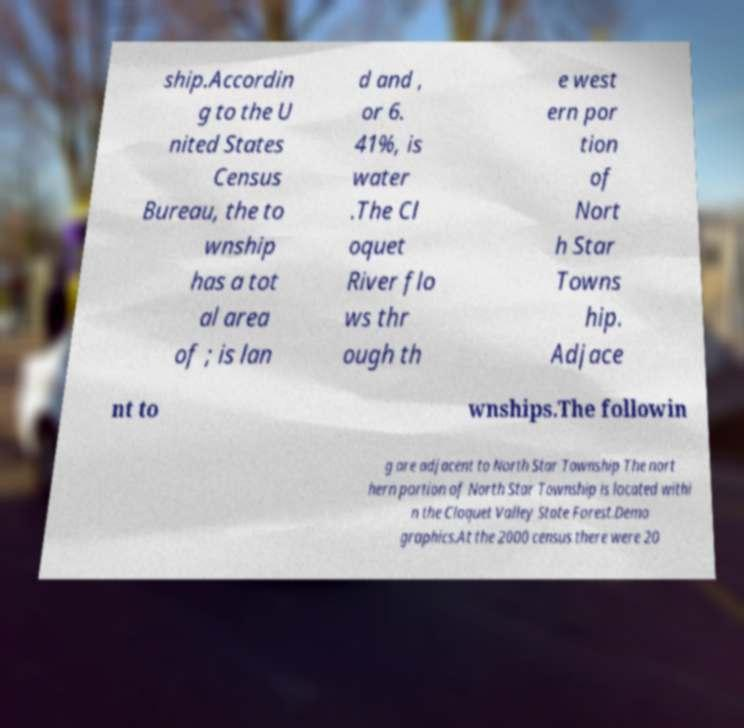Please read and relay the text visible in this image. What does it say? ship.Accordin g to the U nited States Census Bureau, the to wnship has a tot al area of ; is lan d and , or 6. 41%, is water .The Cl oquet River flo ws thr ough th e west ern por tion of Nort h Star Towns hip. Adjace nt to wnships.The followin g are adjacent to North Star Township The nort hern portion of North Star Township is located withi n the Cloquet Valley State Forest.Demo graphics.At the 2000 census there were 20 